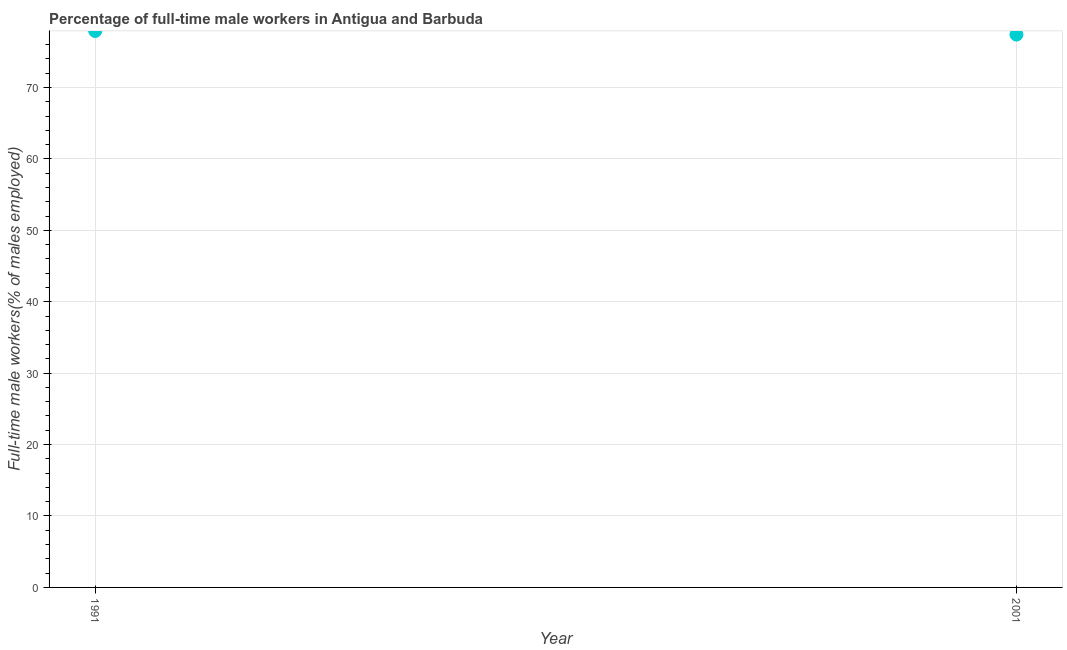What is the percentage of full-time male workers in 1991?
Offer a terse response. 77.9. Across all years, what is the maximum percentage of full-time male workers?
Offer a very short reply. 77.9. Across all years, what is the minimum percentage of full-time male workers?
Your answer should be compact. 77.4. In which year was the percentage of full-time male workers maximum?
Keep it short and to the point. 1991. In which year was the percentage of full-time male workers minimum?
Make the answer very short. 2001. What is the sum of the percentage of full-time male workers?
Make the answer very short. 155.3. What is the difference between the percentage of full-time male workers in 1991 and 2001?
Ensure brevity in your answer.  0.5. What is the average percentage of full-time male workers per year?
Give a very brief answer. 77.65. What is the median percentage of full-time male workers?
Keep it short and to the point. 77.65. In how many years, is the percentage of full-time male workers greater than 38 %?
Provide a succinct answer. 2. Do a majority of the years between 2001 and 1991 (inclusive) have percentage of full-time male workers greater than 52 %?
Make the answer very short. No. What is the ratio of the percentage of full-time male workers in 1991 to that in 2001?
Offer a very short reply. 1.01. Does the percentage of full-time male workers monotonically increase over the years?
Offer a very short reply. No. Does the graph contain any zero values?
Make the answer very short. No. What is the title of the graph?
Your answer should be very brief. Percentage of full-time male workers in Antigua and Barbuda. What is the label or title of the X-axis?
Your answer should be compact. Year. What is the label or title of the Y-axis?
Your answer should be compact. Full-time male workers(% of males employed). What is the Full-time male workers(% of males employed) in 1991?
Provide a short and direct response. 77.9. What is the Full-time male workers(% of males employed) in 2001?
Give a very brief answer. 77.4. What is the difference between the Full-time male workers(% of males employed) in 1991 and 2001?
Keep it short and to the point. 0.5. What is the ratio of the Full-time male workers(% of males employed) in 1991 to that in 2001?
Make the answer very short. 1.01. 